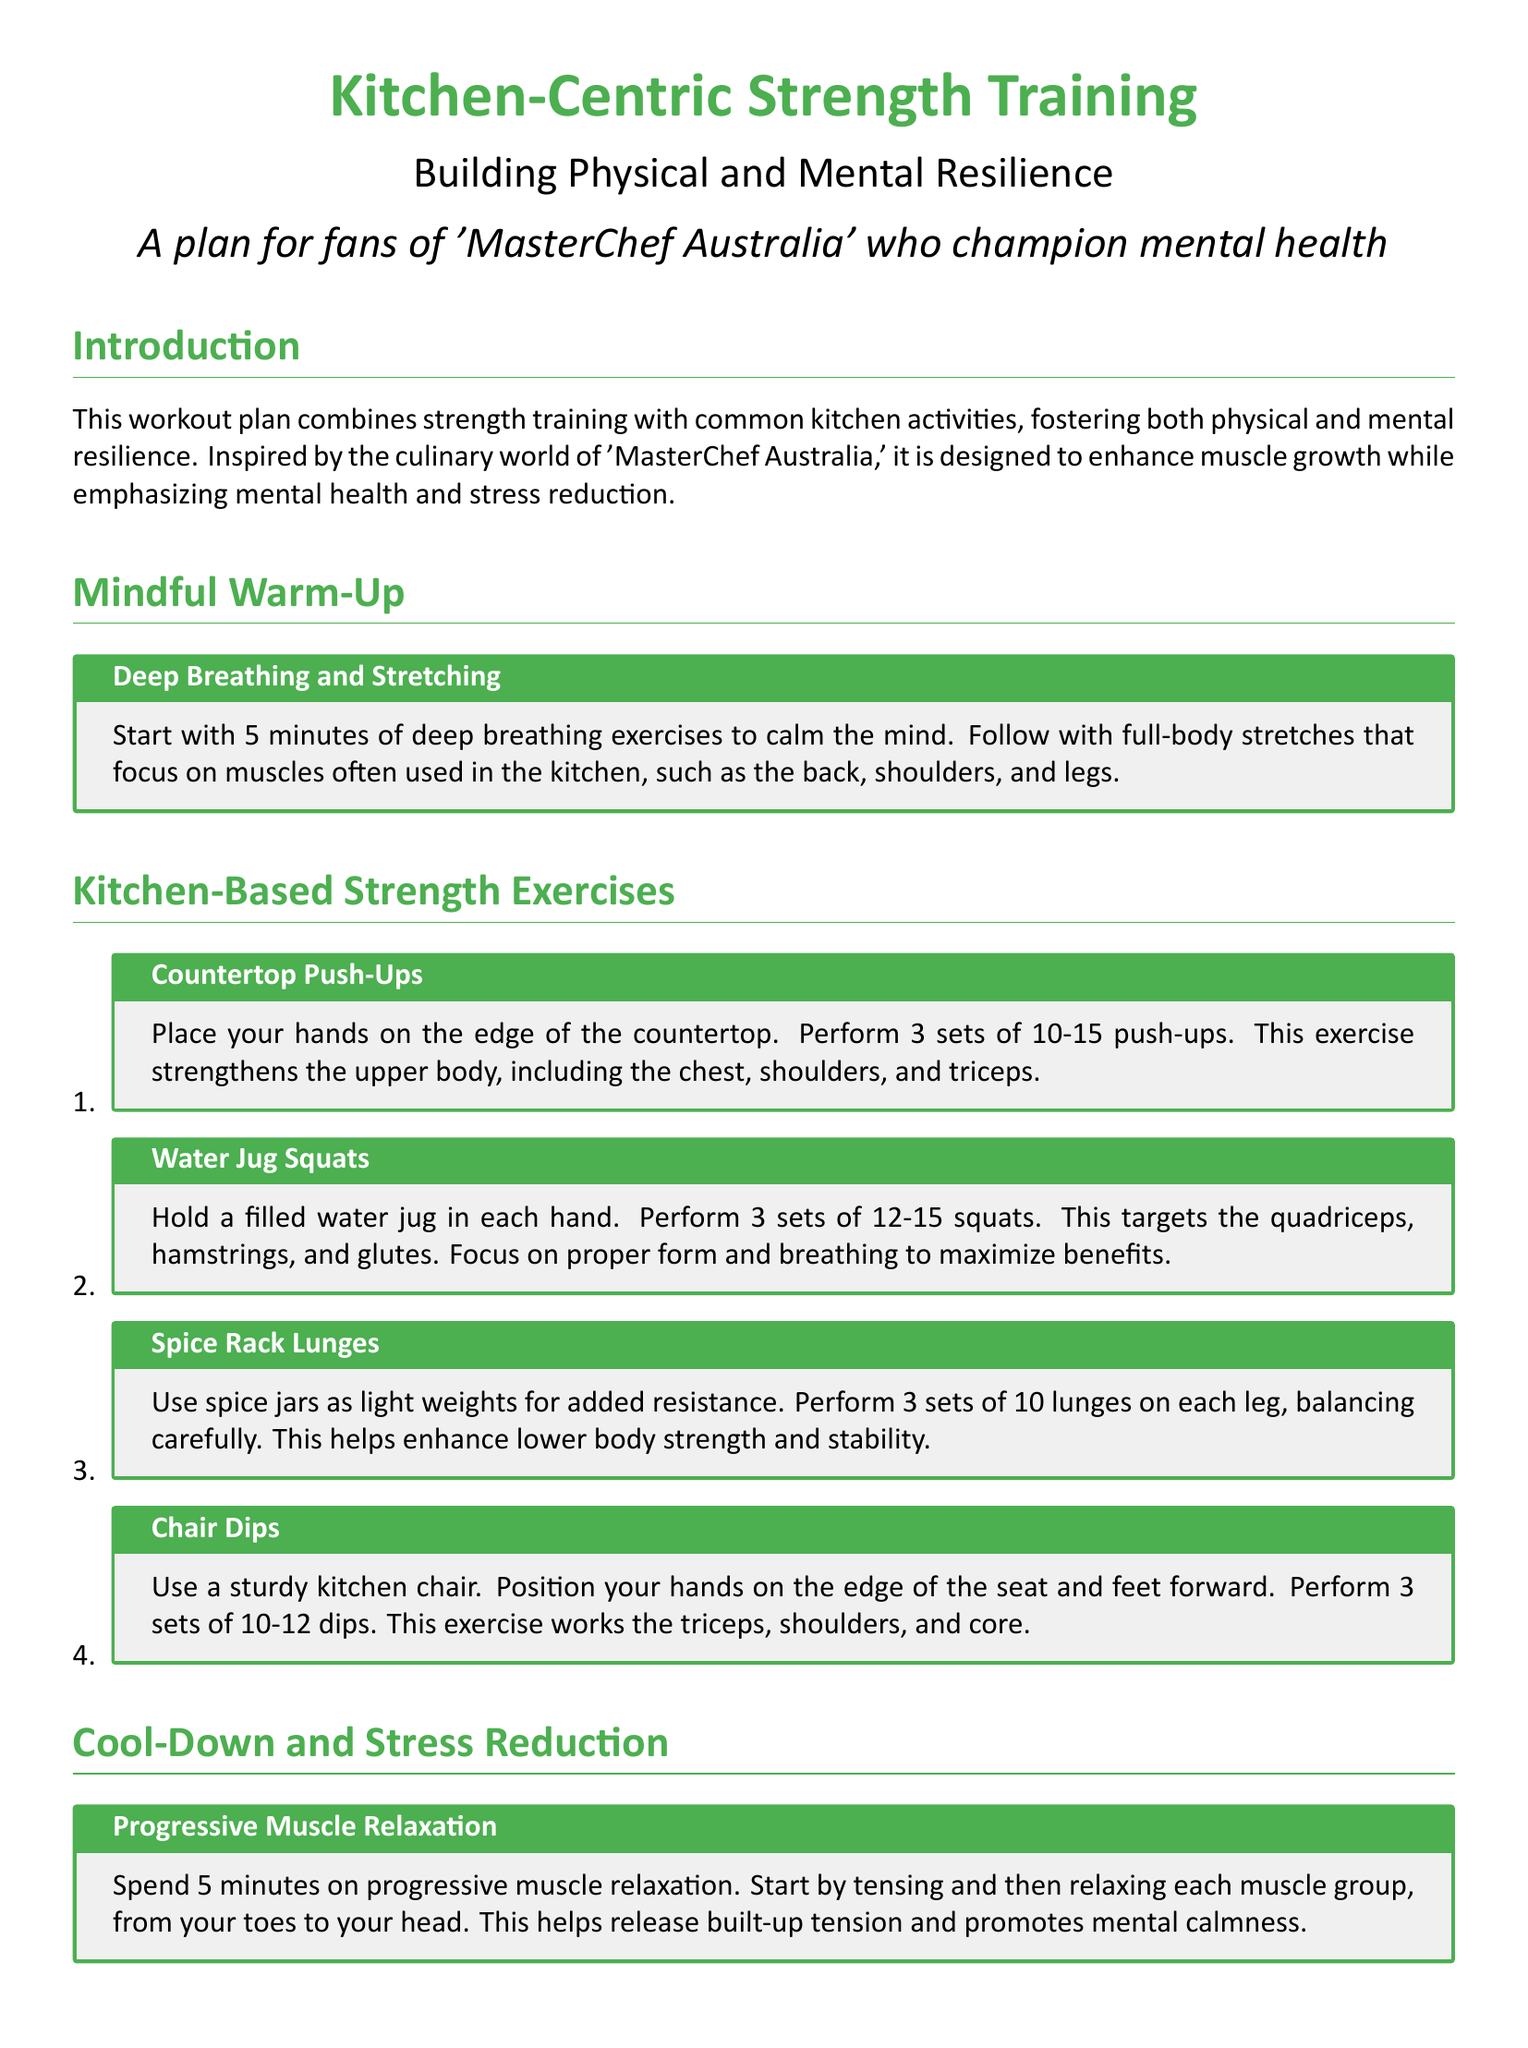What is the title of the workout plan? The title is prominently mentioned at the top of the document, which is "Kitchen-Centric Strength Training."
Answer: Kitchen-Centric Strength Training How many sets are recommended for countertop push-ups? The document specifies the recommended number of sets for countertop push-ups as "3 sets."
Answer: 3 sets What exercise uses filled water jugs? The workout plan includes "Water Jug Squats" that involve holding filled water jugs.
Answer: Water Jug Squats What is the focus of the mindful cooking activity? The mindful cooking activity emphasizes engaging with each ingredient's "texture, aroma, and flavor."
Answer: Texture, aroma, and flavor How long should the cool-down exercise last? The document states that the progressive muscle relaxation should be performed for "5 minutes."
Answer: 5 minutes What muscle group does chair dips primarily work? The chair dips are identified as an exercise that works the "triceps."
Answer: Triceps What is the purpose of deep breathing exercises in the warm-up? The deep breathing exercises are intended to "calm the mind."
Answer: Calm the mind How many lunges are suggested on each leg for spice rack lunges? The plan suggests "10 lunges on each leg."
Answer: 10 lunges on each leg 